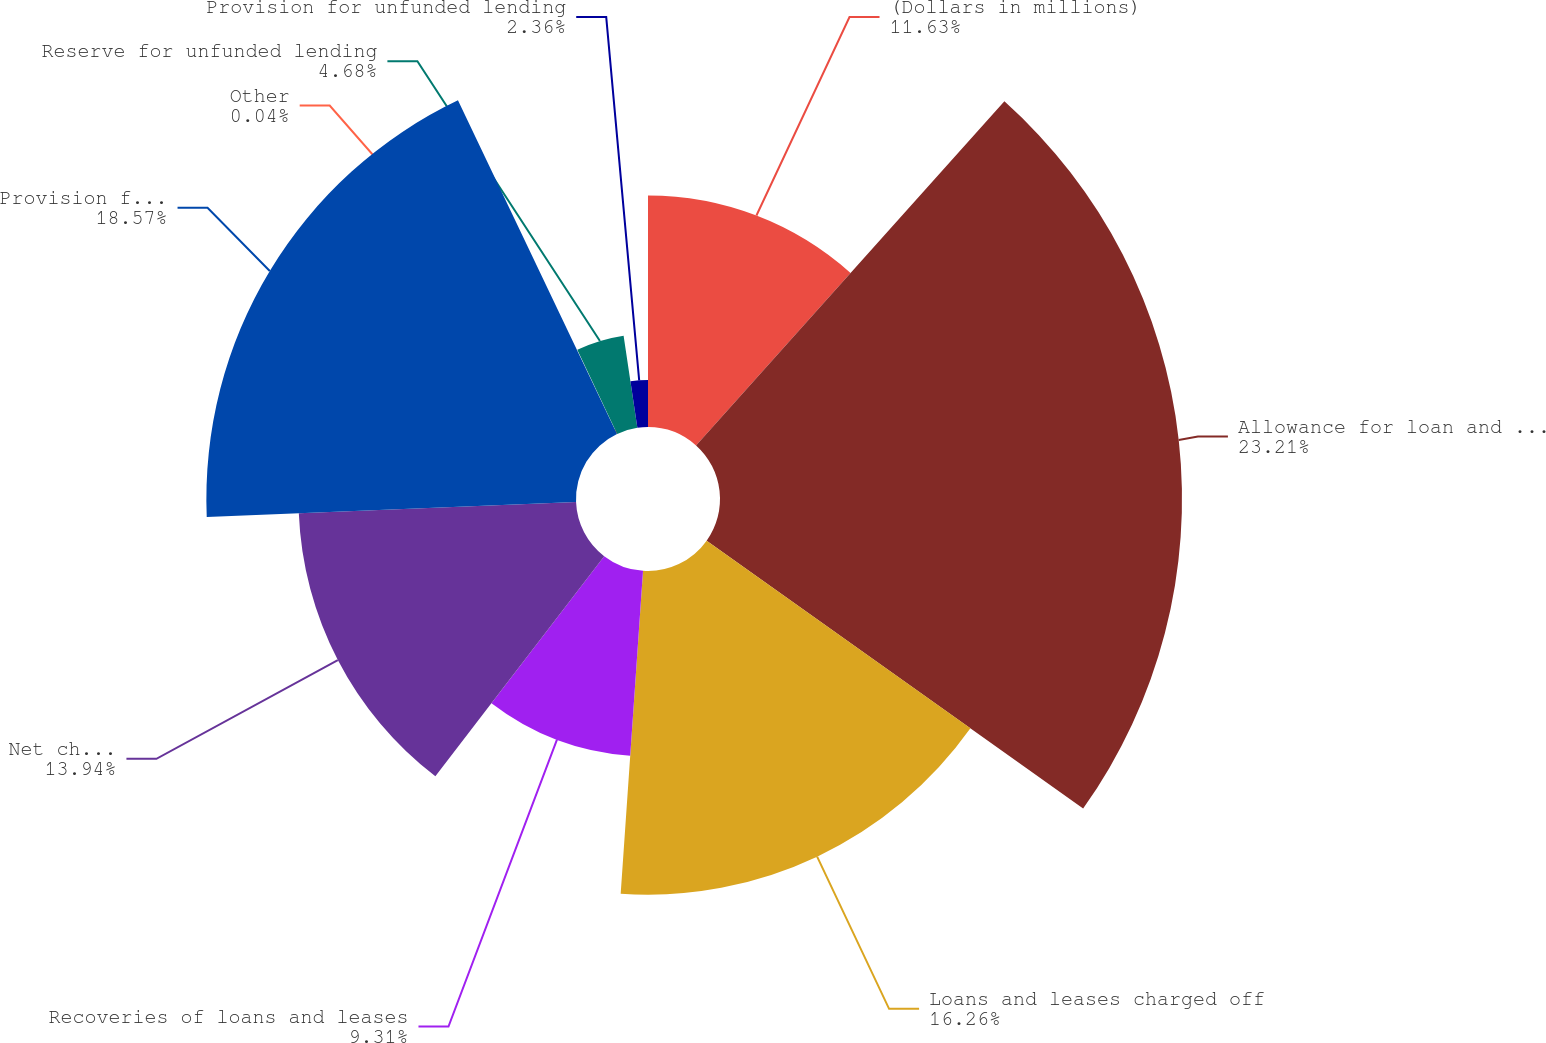Convert chart to OTSL. <chart><loc_0><loc_0><loc_500><loc_500><pie_chart><fcel>(Dollars in millions)<fcel>Allowance for loan and lease<fcel>Loans and leases charged off<fcel>Recoveries of loans and leases<fcel>Net charge-offs<fcel>Provision for loan and lease<fcel>Other<fcel>Reserve for unfunded lending<fcel>Provision for unfunded lending<nl><fcel>11.63%<fcel>23.21%<fcel>16.26%<fcel>9.31%<fcel>13.94%<fcel>18.57%<fcel>0.04%<fcel>4.68%<fcel>2.36%<nl></chart> 